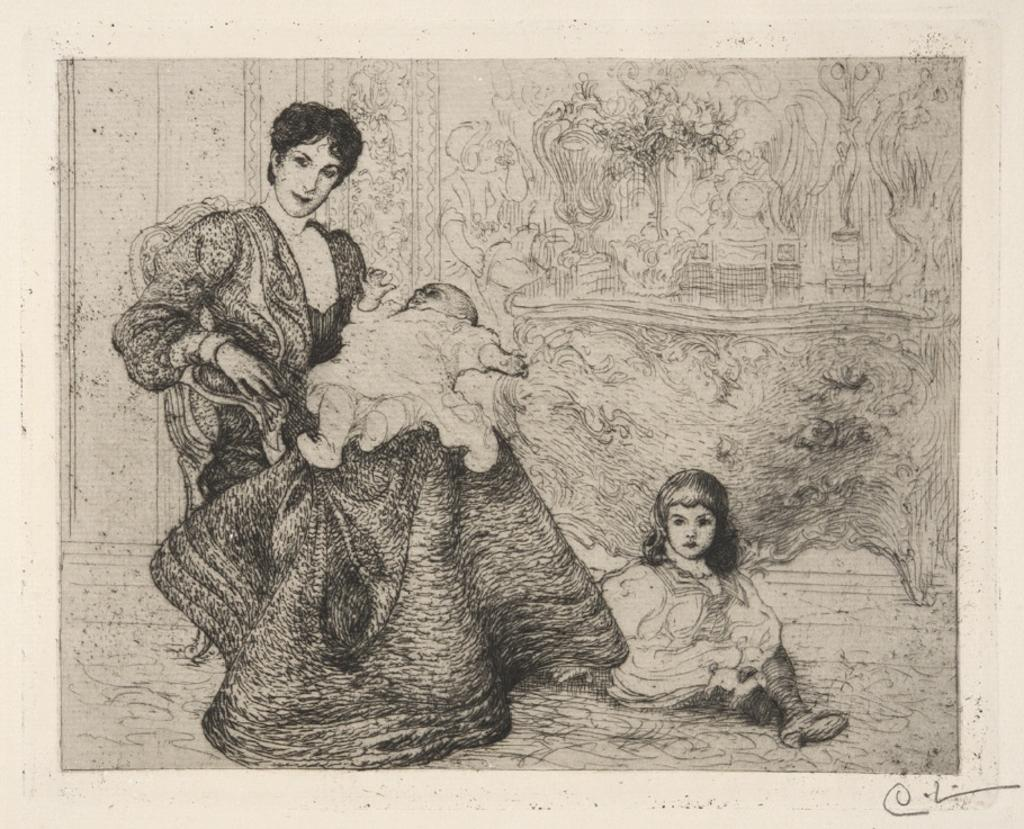What is the main subject of the image? The image contains a painting. Who or what can be seen in the painting? There is a woman sitting on a chair and a girl sitting on the floor in the painting. What is the woman doing in the painting? The woman is holding a baby in the painting. What is visible in the background of the painting? There is a wall in the background of the painting. What type of cloud can be seen in the painting? There is no cloud present in the painting; it is a painting of a woman, a girl, and a baby. What committee is depicted in the painting? There is no committee depicted in the painting; it is a painting of a woman, a girl, and a baby. 